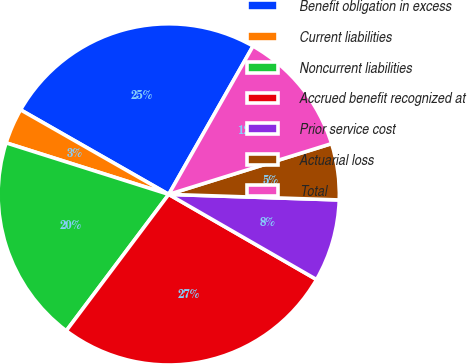<chart> <loc_0><loc_0><loc_500><loc_500><pie_chart><fcel>Benefit obligation in excess<fcel>Current liabilities<fcel>Noncurrent liabilities<fcel>Accrued benefit recognized at<fcel>Prior service cost<fcel>Actuarial loss<fcel>Total<nl><fcel>24.97%<fcel>3.37%<fcel>19.63%<fcel>26.93%<fcel>7.8%<fcel>5.33%<fcel>11.96%<nl></chart> 